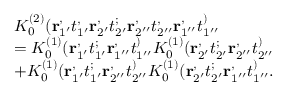<formula> <loc_0><loc_0><loc_500><loc_500>\begin{array} { r l } & { K _ { 0 } ^ { ( 2 ) } ( r _ { 1 ^ { \prime } } ^ { , } t _ { 1 ^ { \prime } } ^ { , } r _ { 2 ^ { \prime } } ^ { , } t _ { 2 ^ { \prime } } ^ { ; } r _ { 2 ^ { \prime \prime } } ^ { , } t _ { 2 ^ { \prime \prime } } ^ { , } r _ { 1 ^ { \prime \prime } } ^ { , } t _ { 1 ^ { \prime \prime } } ^ { ) } } \\ & { = K _ { 0 } ^ { ( 1 ) } ( r _ { 1 ^ { \prime } } ^ { , } t _ { 1 ^ { \prime } } ^ { ; } r _ { 1 ^ { \prime \prime } } ^ { , } t _ { 1 ^ { \prime \prime } } ^ { ) } K _ { 0 } ^ { ( 1 ) } ( r _ { 2 ^ { \prime } } ^ { , } t _ { 2 ^ { \prime } } ^ { ; } r _ { 2 ^ { \prime \prime } } ^ { , } t _ { 2 ^ { \prime \prime } } ^ { ) } } \\ & { + K _ { 0 } ^ { ( 1 ) } ( r _ { 1 ^ { \prime } } ^ { , } t _ { 1 ^ { \prime } } ^ { ; } r _ { 2 ^ { \prime \prime } } ^ { , } t _ { 2 ^ { \prime \prime } } ^ { ) } K _ { 0 } ^ { ( 1 ) } ( r _ { 2 ^ { \prime } } ^ { , } t _ { 2 ^ { \prime } } ^ { ; } r _ { 1 ^ { \prime \prime } } ^ { , } t _ { 1 ^ { \prime \prime } } ^ { ) } . } \end{array}</formula> 